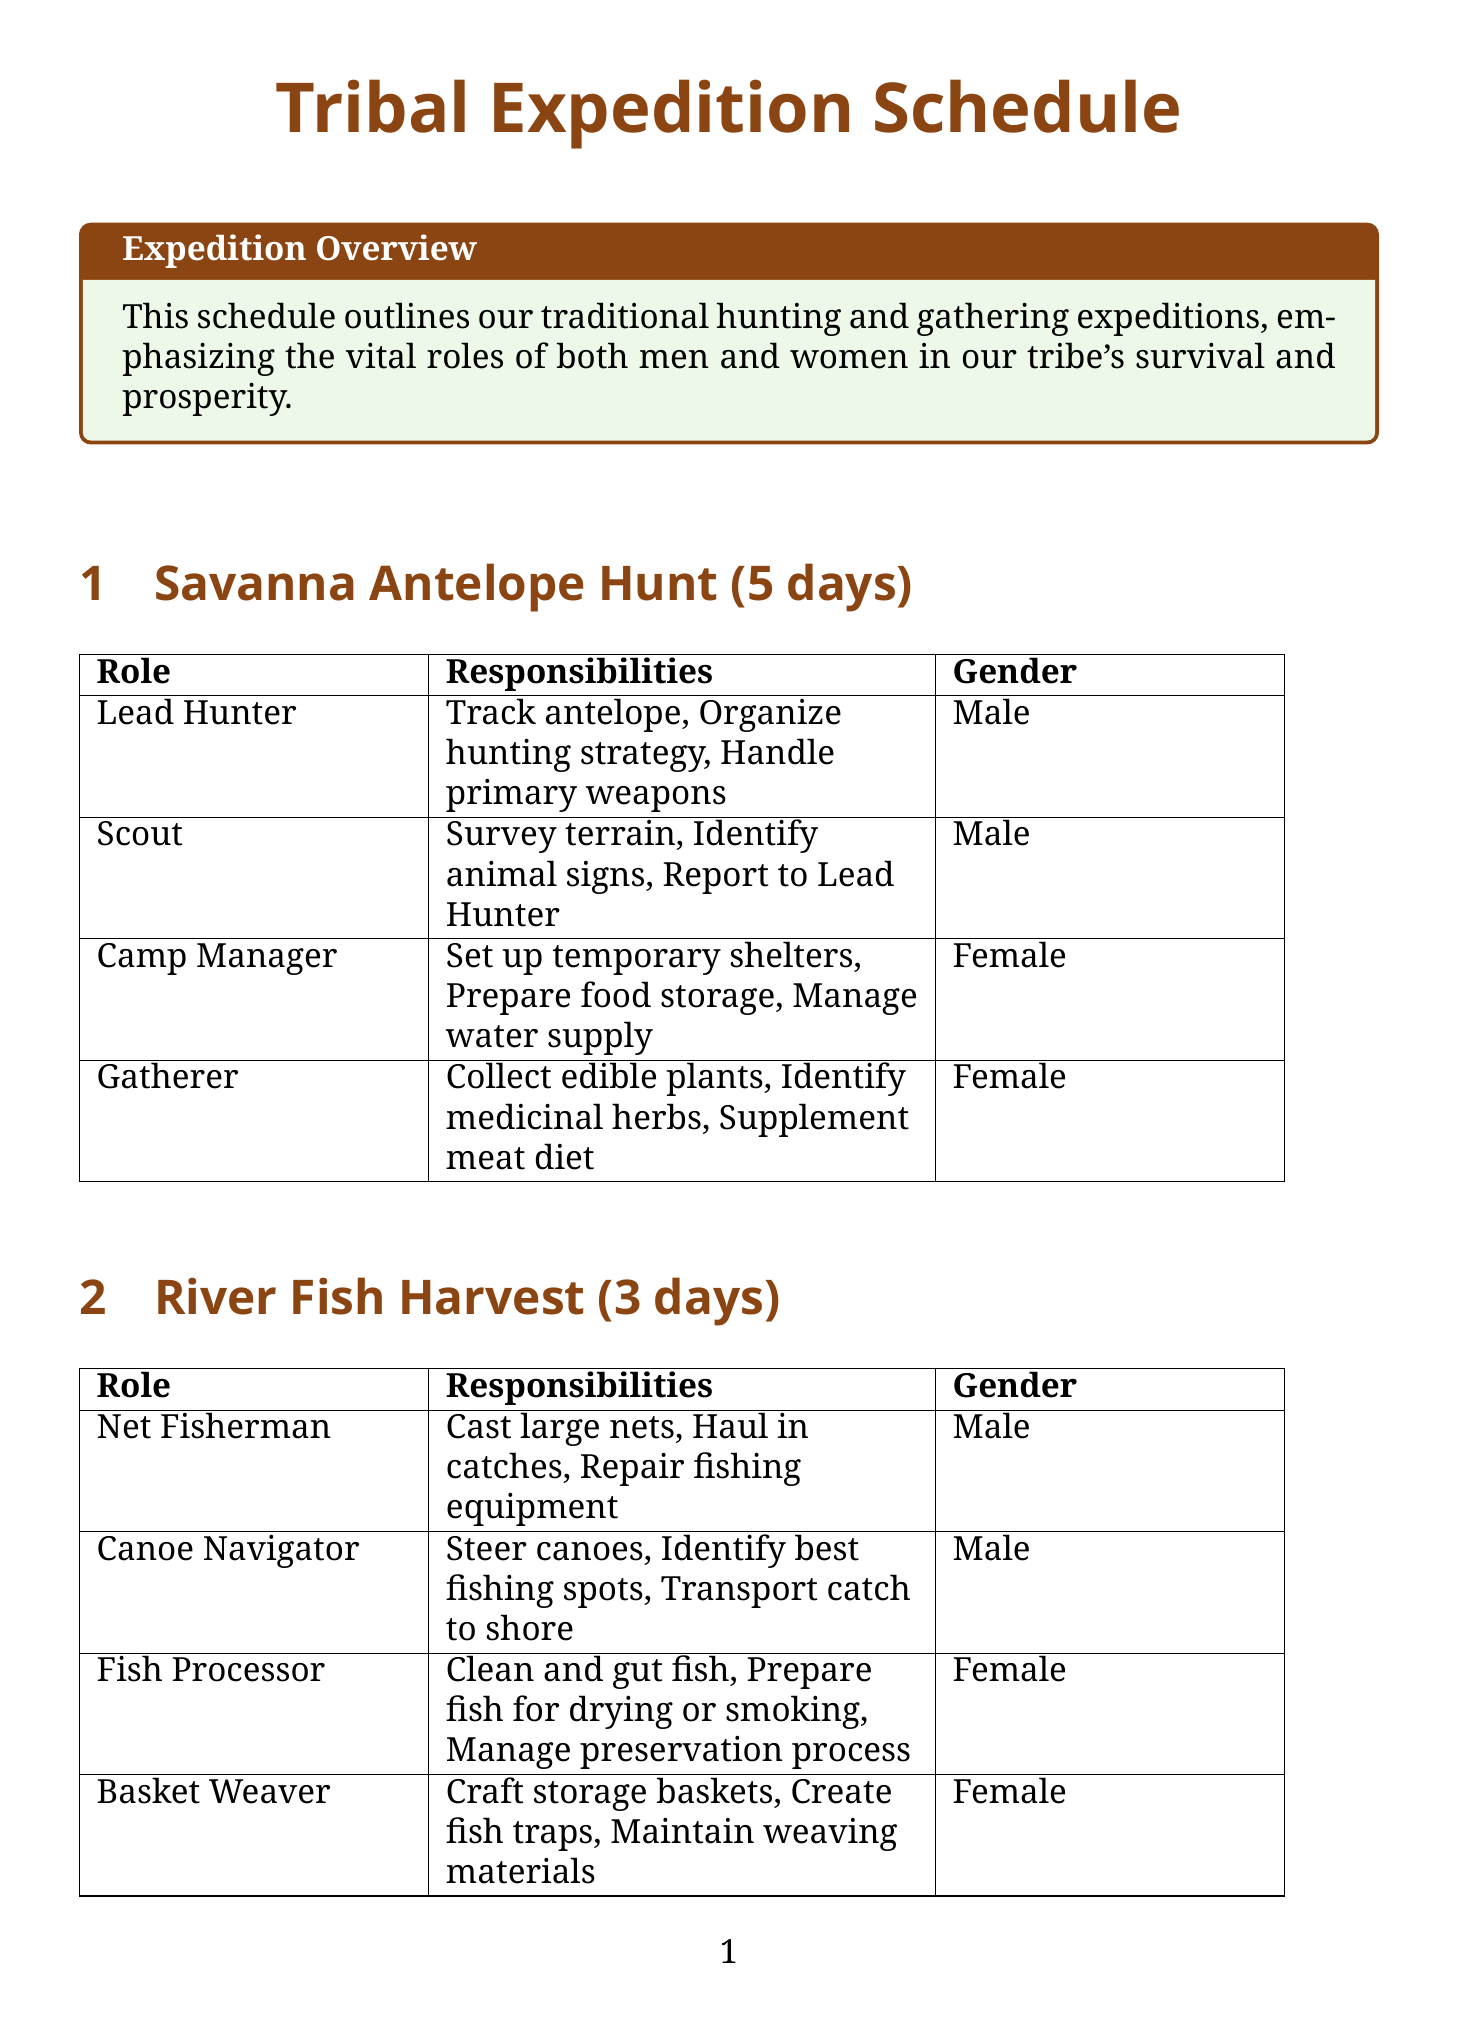What is the duration of the Savanna Antelope Hunt? The duration of the Savanna Antelope Hunt is specified in the document.
Answer: 5 days Who is responsible for managing the water supply in the Savanna Antelope Hunt? The Camp Manager is assigned the role related to managing the water supply during this expedition.
Answer: Camp Manager How many male roles are assigned in the River Fish Harvest expedition? The document lists the male roles assigned in the River Fish Harvest expedition.
Answer: 2 What is the role of the Ground Collector in the Forest Fruit Collection? The Ground Collector's responsibilities are detailed in the document under the Forest Fruit Collection section.
Answer: Gather fallen fruits What is the primary responsibility of the Shell Cleaner? The Shell Cleaner is responsible for a specific task outlined in the Coastal Shellfish Collection.
Answer: Remove sand and debris What type of expedition lasts the longest? The expeditions are compared based on their duration mentioned in the document.
Answer: Savanna Antelope Hunt Which female role is involved in crafting storage baskets in the River Fish Harvest? The document specifically identifies the female role responsible for crafting storage baskets in this expedition.
Answer: Basket Weaver How many days does the Grassland Tuber Dig last? The document provides the duration for the Grassland Tuber Dig expedition.
Answer: 4 days 